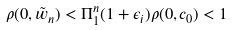<formula> <loc_0><loc_0><loc_500><loc_500>\rho ( 0 , \tilde { w } _ { n } ) < \Pi _ { 1 } ^ { n } ( 1 + \epsilon _ { i } ) \rho ( 0 , c _ { 0 } ) < 1</formula> 